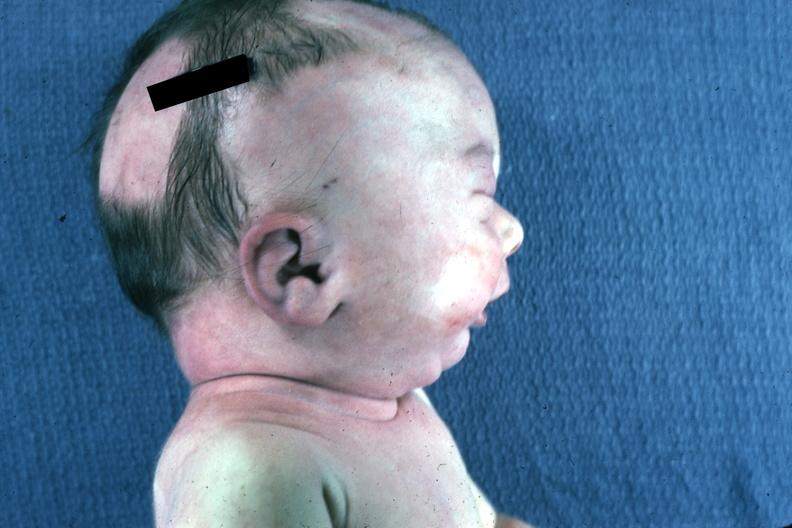what is present?
Answer the question using a single word or phrase. Potters facies 